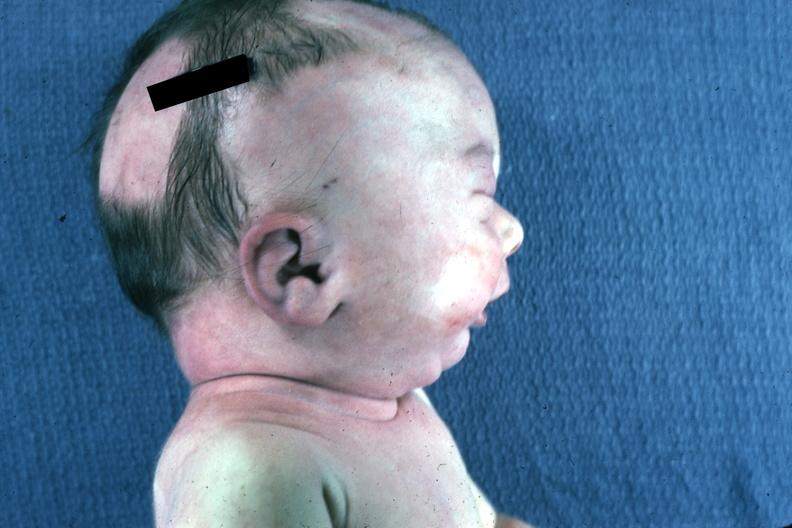what is present?
Answer the question using a single word or phrase. Potters facies 